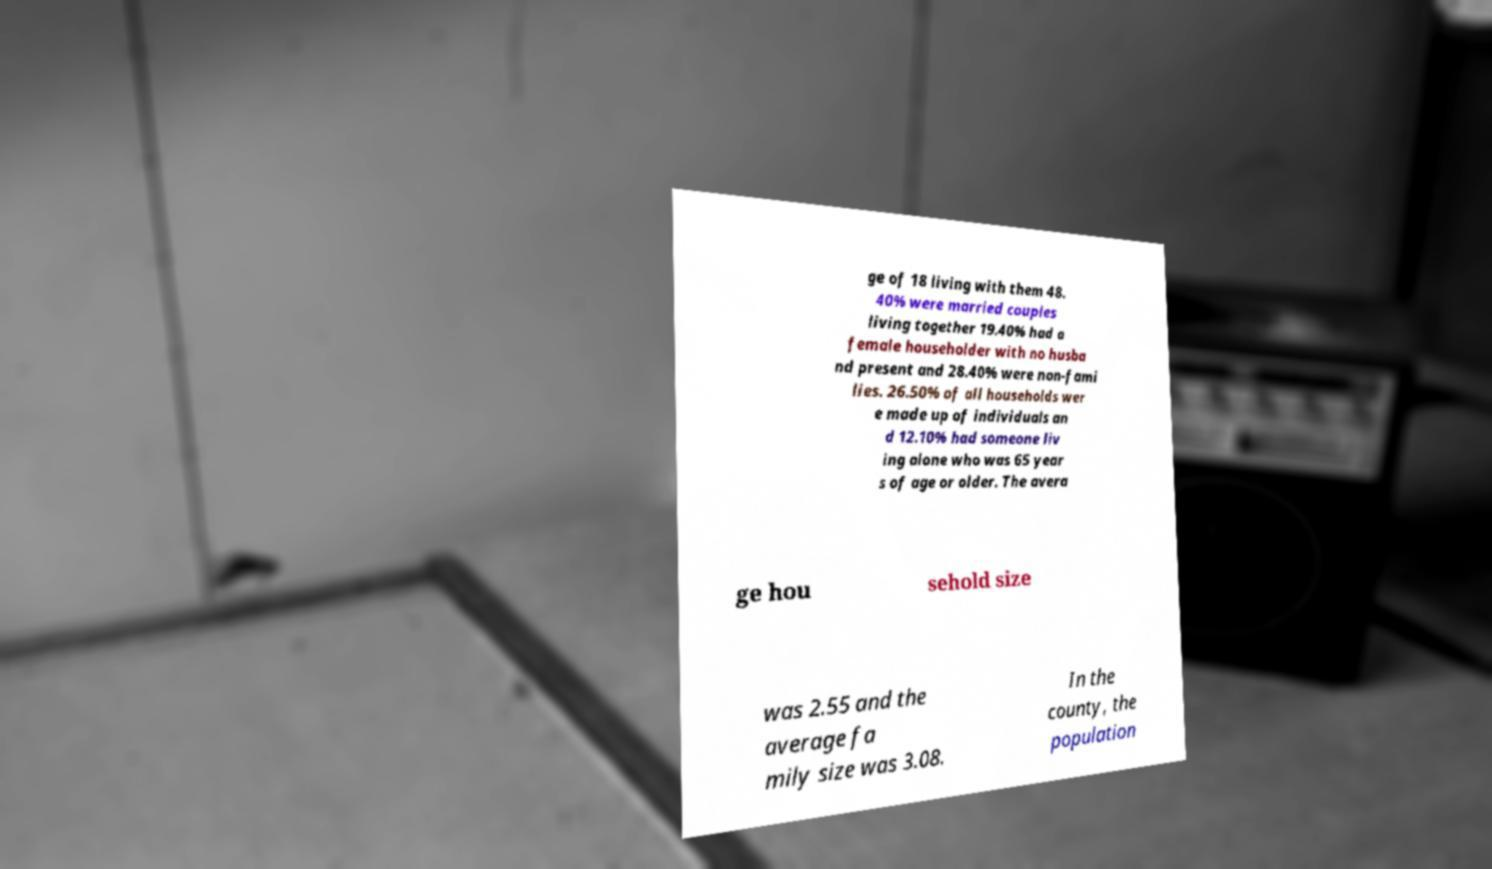Can you accurately transcribe the text from the provided image for me? ge of 18 living with them 48. 40% were married couples living together 19.40% had a female householder with no husba nd present and 28.40% were non-fami lies. 26.50% of all households wer e made up of individuals an d 12.10% had someone liv ing alone who was 65 year s of age or older. The avera ge hou sehold size was 2.55 and the average fa mily size was 3.08. In the county, the population 